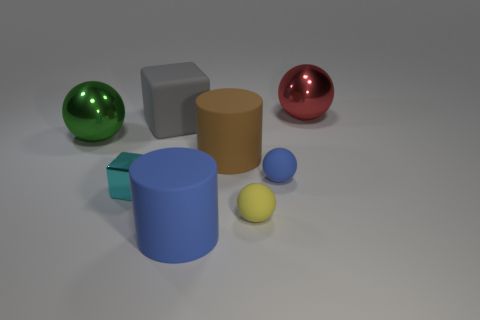Subtract all gray spheres. Subtract all cyan cylinders. How many spheres are left? 4 Add 1 big metal blocks. How many objects exist? 9 Subtract all cubes. How many objects are left? 6 Add 3 big purple rubber cubes. How many big purple rubber cubes exist? 3 Subtract 1 blue spheres. How many objects are left? 7 Subtract all large green metallic objects. Subtract all green objects. How many objects are left? 6 Add 5 rubber balls. How many rubber balls are left? 7 